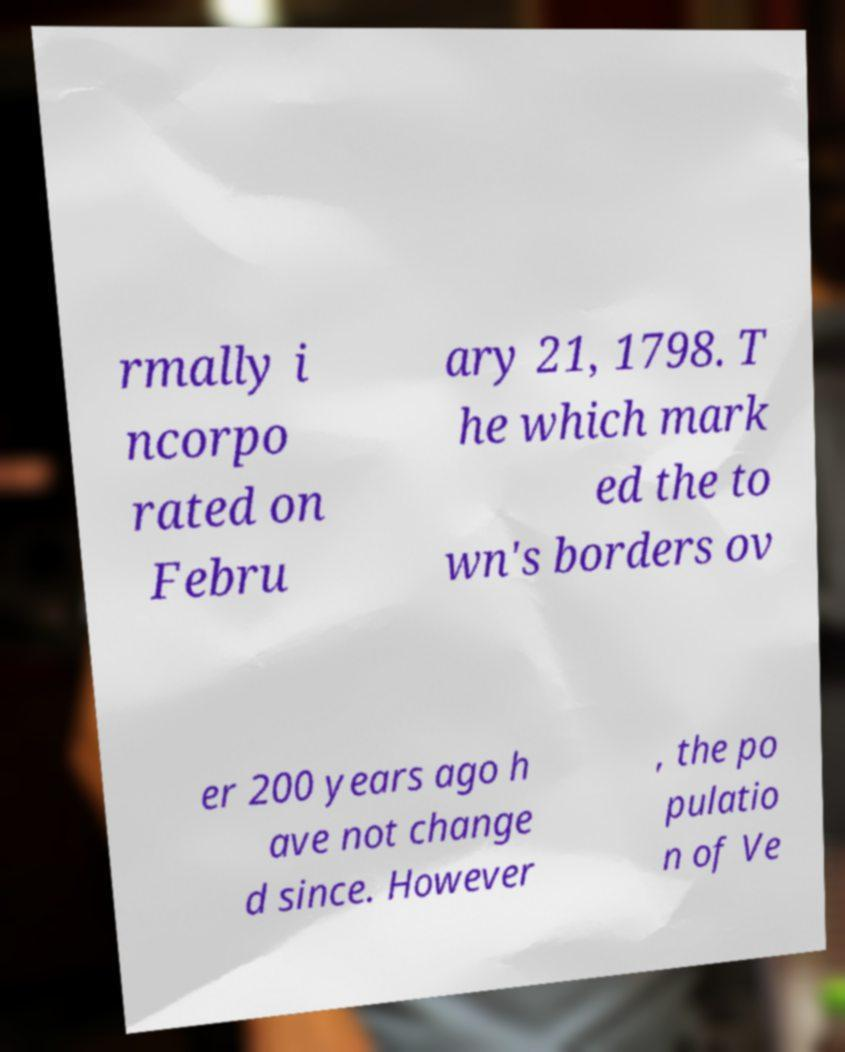There's text embedded in this image that I need extracted. Can you transcribe it verbatim? rmally i ncorpo rated on Febru ary 21, 1798. T he which mark ed the to wn's borders ov er 200 years ago h ave not change d since. However , the po pulatio n of Ve 